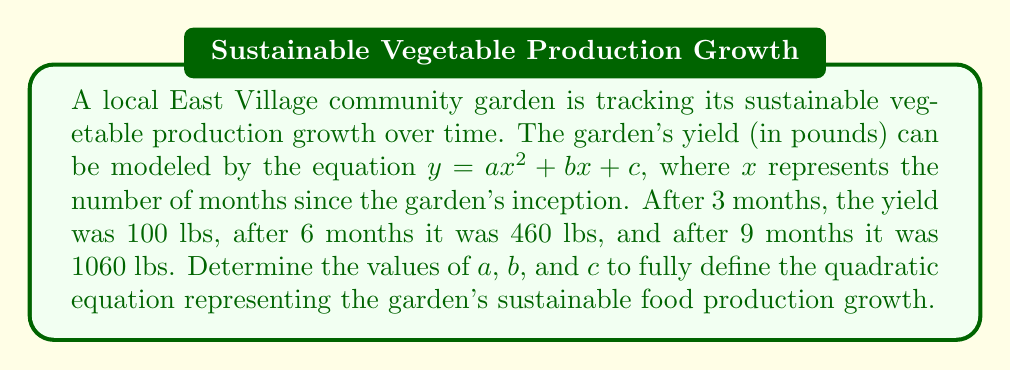Teach me how to tackle this problem. Let's approach this step-by-step:

1) We have three points that satisfy the equation $y = ax^2 + bx + c$:
   $(3, 100)$, $(6, 460)$, and $(9, 1060)$

2) Let's substitute these points into the equation:
   $100 = 9a + 3b + c$    (Equation 1)
   $460 = 36a + 6b + c$   (Equation 2)
   $1060 = 81a + 9b + c$  (Equation 3)

3) Subtract Equation 1 from Equation 2:
   $360 = 27a + 3b$
   $120 = 9a + b$         (Equation 4)

4) Subtract Equation 2 from Equation 3:
   $600 = 45a + 3b$
   $200 = 15a + b$        (Equation 5)

5) Subtract Equation 4 from Equation 5:
   $80 = 6a$
   $a = \frac{80}{6} = \frac{40}{3}$

6) Substitute $a = \frac{40}{3}$ into Equation 4:
   $120 = 9(\frac{40}{3}) + b$
   $120 = 120 + b$
   $b = 0$

7) Substitute $a = \frac{40}{3}$ and $b = 0$ into Equation 1:
   $100 = 9(\frac{40}{3}) + 3(0) + c$
   $100 = 120 + c$
   $c = -20$

Therefore, the equation is $y = \frac{40}{3}x^2 + 0x - 20$ or simplified: $y = \frac{40}{3}x^2 - 20$
Answer: $y = \frac{40}{3}x^2 - 20$ 